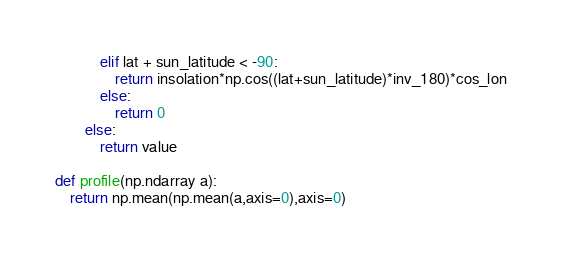Convert code to text. <code><loc_0><loc_0><loc_500><loc_500><_Cython_>			elif lat + sun_latitude < -90:
				return insolation*np.cos((lat+sun_latitude)*inv_180)*cos_lon
			else:
				return 0
		else:
			return value

def profile(np.ndarray a):
	return np.mean(np.mean(a,axis=0),axis=0)
</code> 